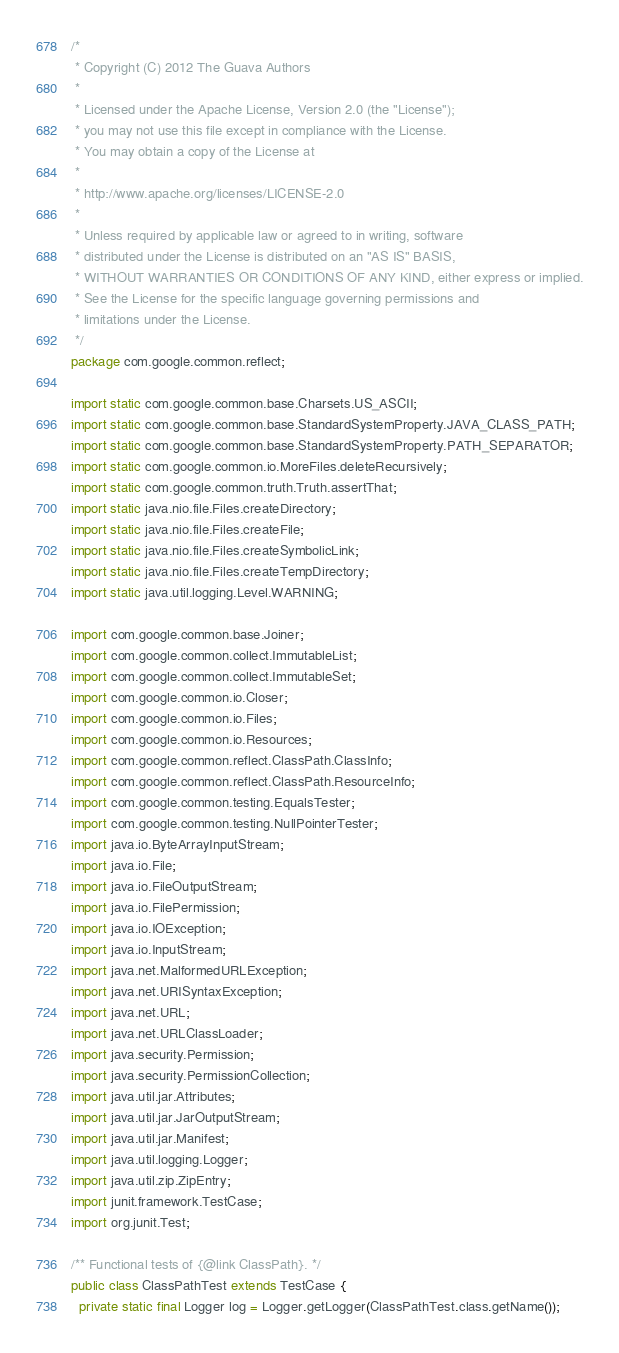<code> <loc_0><loc_0><loc_500><loc_500><_Java_>/*
 * Copyright (C) 2012 The Guava Authors
 *
 * Licensed under the Apache License, Version 2.0 (the "License");
 * you may not use this file except in compliance with the License.
 * You may obtain a copy of the License at
 *
 * http://www.apache.org/licenses/LICENSE-2.0
 *
 * Unless required by applicable law or agreed to in writing, software
 * distributed under the License is distributed on an "AS IS" BASIS,
 * WITHOUT WARRANTIES OR CONDITIONS OF ANY KIND, either express or implied.
 * See the License for the specific language governing permissions and
 * limitations under the License.
 */
package com.google.common.reflect;

import static com.google.common.base.Charsets.US_ASCII;
import static com.google.common.base.StandardSystemProperty.JAVA_CLASS_PATH;
import static com.google.common.base.StandardSystemProperty.PATH_SEPARATOR;
import static com.google.common.io.MoreFiles.deleteRecursively;
import static com.google.common.truth.Truth.assertThat;
import static java.nio.file.Files.createDirectory;
import static java.nio.file.Files.createFile;
import static java.nio.file.Files.createSymbolicLink;
import static java.nio.file.Files.createTempDirectory;
import static java.util.logging.Level.WARNING;

import com.google.common.base.Joiner;
import com.google.common.collect.ImmutableList;
import com.google.common.collect.ImmutableSet;
import com.google.common.io.Closer;
import com.google.common.io.Files;
import com.google.common.io.Resources;
import com.google.common.reflect.ClassPath.ClassInfo;
import com.google.common.reflect.ClassPath.ResourceInfo;
import com.google.common.testing.EqualsTester;
import com.google.common.testing.NullPointerTester;
import java.io.ByteArrayInputStream;
import java.io.File;
import java.io.FileOutputStream;
import java.io.FilePermission;
import java.io.IOException;
import java.io.InputStream;
import java.net.MalformedURLException;
import java.net.URISyntaxException;
import java.net.URL;
import java.net.URLClassLoader;
import java.security.Permission;
import java.security.PermissionCollection;
import java.util.jar.Attributes;
import java.util.jar.JarOutputStream;
import java.util.jar.Manifest;
import java.util.logging.Logger;
import java.util.zip.ZipEntry;
import junit.framework.TestCase;
import org.junit.Test;

/** Functional tests of {@link ClassPath}. */
public class ClassPathTest extends TestCase {
  private static final Logger log = Logger.getLogger(ClassPathTest.class.getName());</code> 